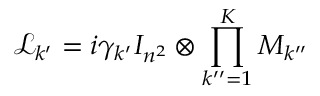<formula> <loc_0><loc_0><loc_500><loc_500>\mathcal { L } _ { k ^ { \prime } } = i \gamma _ { k ^ { \prime } } I _ { n ^ { 2 } } \otimes \prod _ { k ^ { \prime \prime } = 1 } ^ { K } M _ { k ^ { \prime \prime } }</formula> 